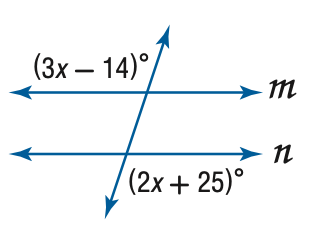Answer the mathemtical geometry problem and directly provide the correct option letter.
Question: Find x so that m \parallel n.
Choices: A: 11 B: 38.2 C: 39 D: 103 C 